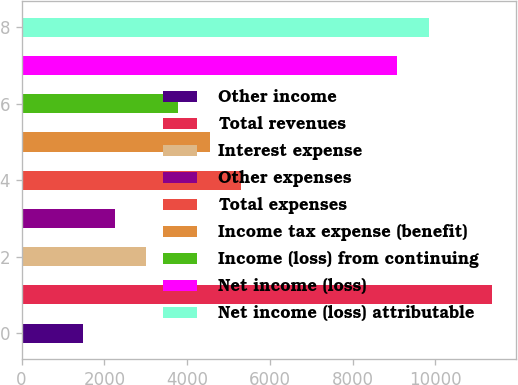Convert chart to OTSL. <chart><loc_0><loc_0><loc_500><loc_500><bar_chart><fcel>Other income<fcel>Total revenues<fcel>Interest expense<fcel>Other expenses<fcel>Total expenses<fcel>Income tax expense (benefit)<fcel>Income (loss) from continuing<fcel>Net income (loss)<fcel>Net income (loss) attributable<nl><fcel>1487<fcel>11376.4<fcel>3014.6<fcel>2250.8<fcel>5306<fcel>4542.2<fcel>3778.4<fcel>9085<fcel>9848.8<nl></chart> 